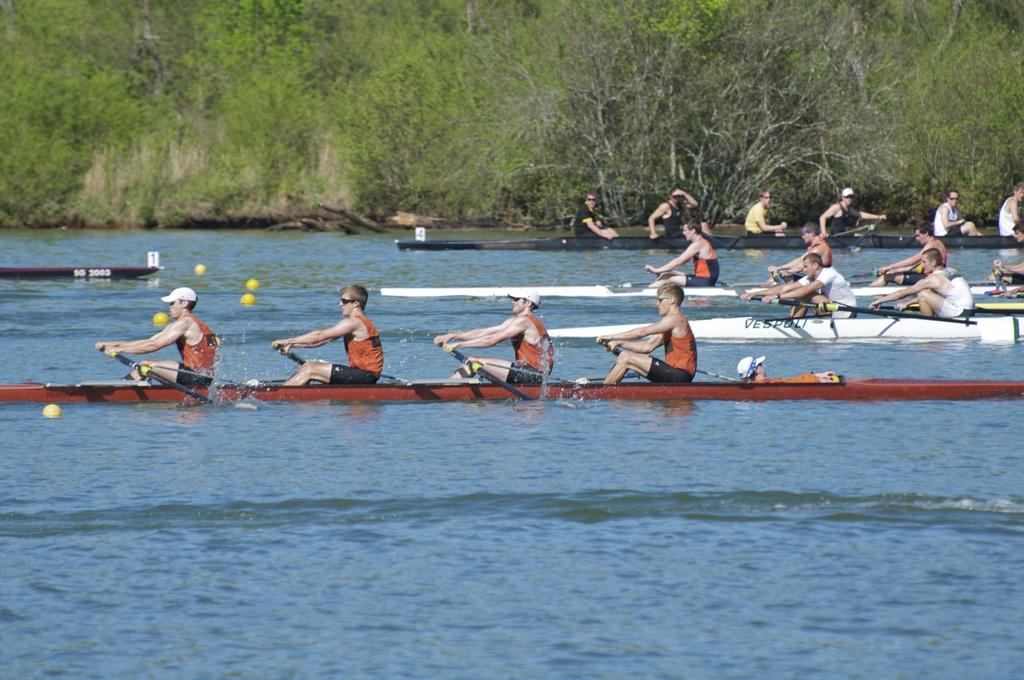How many people are in the boat in the image? There are four persons sitting in a boat in the image. What is visible at the bottom of the image? There is water visible at the bottom of the image. What can be seen in the background of the image? There are trees in the background of the image. How many boats are present in the image? There are five boats in the image. What type of plant is growing on the boat in the image? There is no plant growing on the boat in the image. Can you see any geese or fowl in the image? There are no geese or fowl present in the image. 